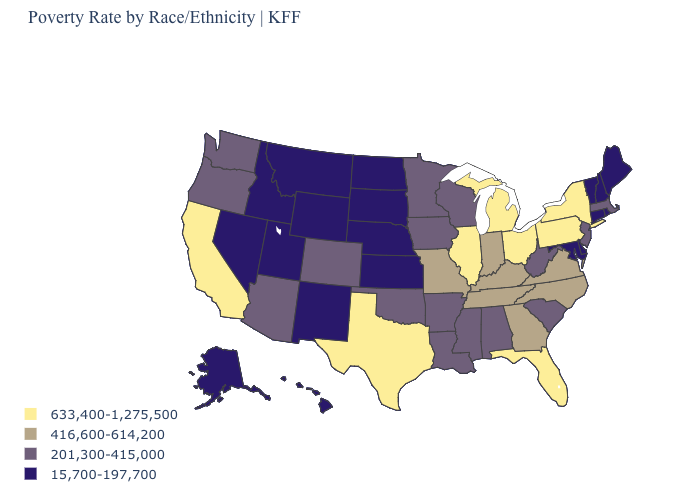What is the value of Iowa?
Give a very brief answer. 201,300-415,000. What is the value of Rhode Island?
Quick response, please. 15,700-197,700. Name the states that have a value in the range 15,700-197,700?
Give a very brief answer. Alaska, Connecticut, Delaware, Hawaii, Idaho, Kansas, Maine, Maryland, Montana, Nebraska, Nevada, New Hampshire, New Mexico, North Dakota, Rhode Island, South Dakota, Utah, Vermont, Wyoming. Name the states that have a value in the range 201,300-415,000?
Short answer required. Alabama, Arizona, Arkansas, Colorado, Iowa, Louisiana, Massachusetts, Minnesota, Mississippi, New Jersey, Oklahoma, Oregon, South Carolina, Washington, West Virginia, Wisconsin. Name the states that have a value in the range 201,300-415,000?
Give a very brief answer. Alabama, Arizona, Arkansas, Colorado, Iowa, Louisiana, Massachusetts, Minnesota, Mississippi, New Jersey, Oklahoma, Oregon, South Carolina, Washington, West Virginia, Wisconsin. Name the states that have a value in the range 201,300-415,000?
Concise answer only. Alabama, Arizona, Arkansas, Colorado, Iowa, Louisiana, Massachusetts, Minnesota, Mississippi, New Jersey, Oklahoma, Oregon, South Carolina, Washington, West Virginia, Wisconsin. What is the value of Illinois?
Keep it brief. 633,400-1,275,500. What is the lowest value in the USA?
Answer briefly. 15,700-197,700. What is the lowest value in the MidWest?
Answer briefly. 15,700-197,700. Among the states that border Indiana , does Kentucky have the highest value?
Concise answer only. No. What is the highest value in the MidWest ?
Answer briefly. 633,400-1,275,500. What is the value of Vermont?
Answer briefly. 15,700-197,700. Name the states that have a value in the range 416,600-614,200?
Keep it brief. Georgia, Indiana, Kentucky, Missouri, North Carolina, Tennessee, Virginia. Which states have the lowest value in the MidWest?
Quick response, please. Kansas, Nebraska, North Dakota, South Dakota. Does California have the highest value in the West?
Be succinct. Yes. 